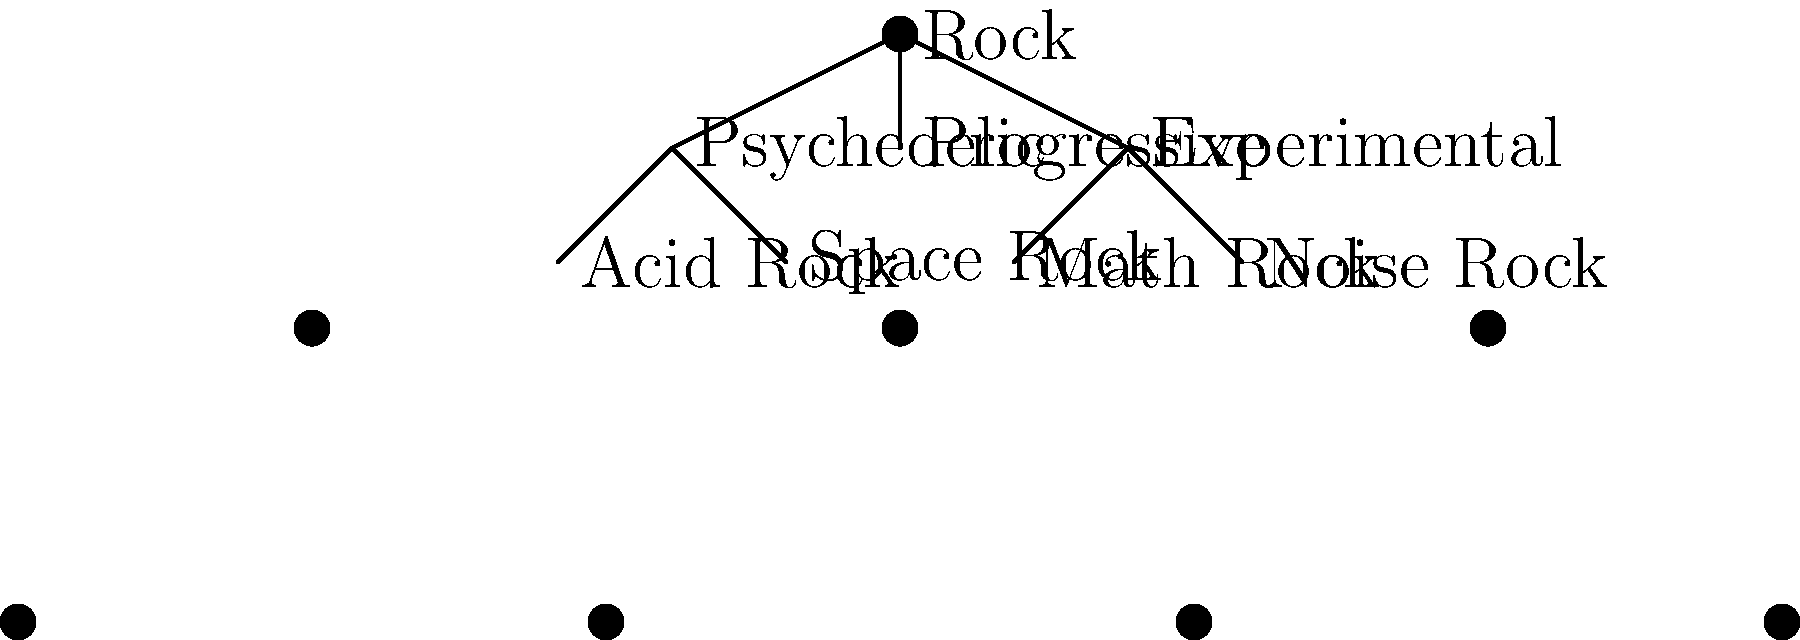In this hierarchical tree diagram of rock subgenres, which category does Space Rock fall under, and what other subgenre shares the same parent category? To answer this question, let's analyze the hierarchical tree diagram step-by-step:

1. The diagram shows "Rock" as the root node, representing the main genre.

2. There are three main subgenres branching from "Rock":
   a) Psychedelic
   b) Progressive
   c) Experimental

3. "Space Rock" is shown as a leaf node in the diagram.

4. We can see that "Space Rock" is connected to the "Psychedelic" node, indicating that it falls under the Psychedelic rock category.

5. To find what other subgenre shares the same parent category, we need to look at the other leaf node connected to "Psychedelic".

6. We can see that "Acid Rock" is also connected to the "Psychedelic" node.

Therefore, Space Rock falls under the Psychedelic rock category, and Acid Rock shares the same parent category.
Answer: Psychedelic; Acid Rock 